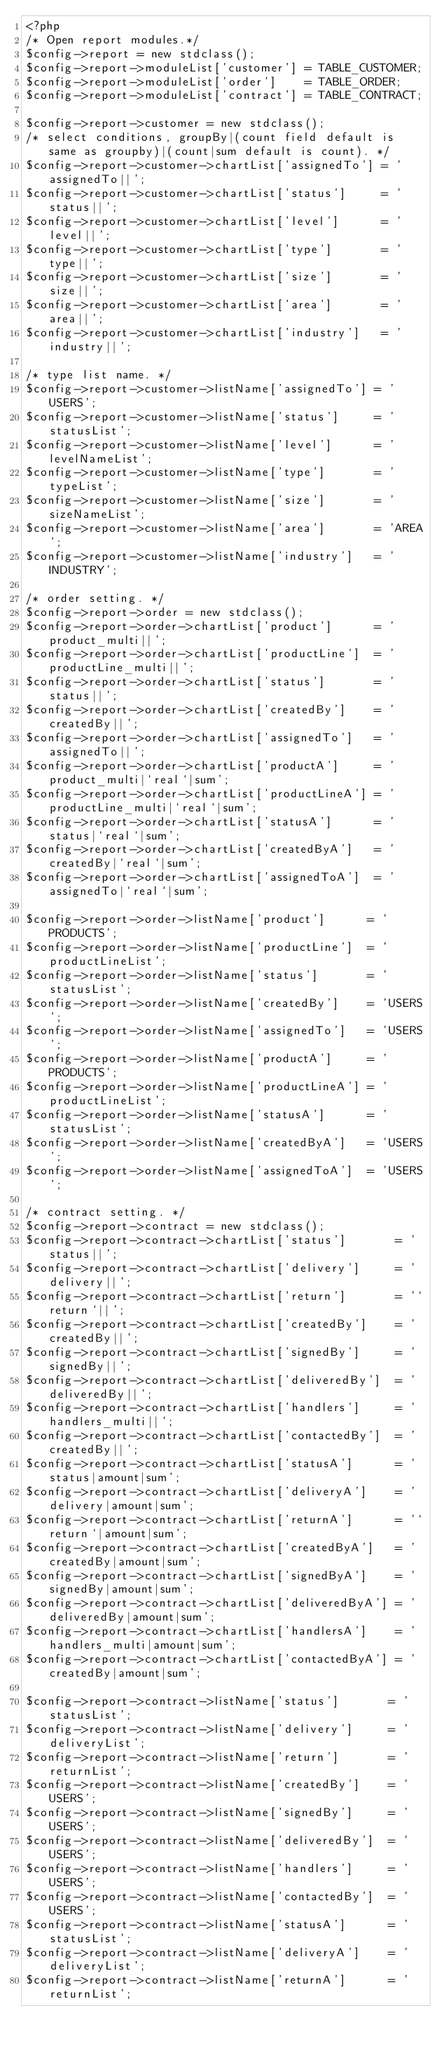Convert code to text. <code><loc_0><loc_0><loc_500><loc_500><_PHP_><?php
/* Open report modules.*/
$config->report = new stdclass();
$config->report->moduleList['customer'] = TABLE_CUSTOMER;
$config->report->moduleList['order']    = TABLE_ORDER;
$config->report->moduleList['contract'] = TABLE_CONTRACT;

$config->report->customer = new stdclass();
/* select conditions, groupBy|(count field default is same as groupby)|(count|sum default is count). */
$config->report->customer->chartList['assignedTo'] = 'assignedTo||';
$config->report->customer->chartList['status']     = 'status||';
$config->report->customer->chartList['level']      = 'level||';
$config->report->customer->chartList['type']       = 'type||';
$config->report->customer->chartList['size']       = 'size||';
$config->report->customer->chartList['area']       = 'area||';
$config->report->customer->chartList['industry']   = 'industry||';

/* type list name. */
$config->report->customer->listName['assignedTo'] = 'USERS';
$config->report->customer->listName['status']     = 'statusList';
$config->report->customer->listName['level']      = 'levelNameList';
$config->report->customer->listName['type']       = 'typeList';
$config->report->customer->listName['size']       = 'sizeNameList';
$config->report->customer->listName['area']       = 'AREA';
$config->report->customer->listName['industry']   = 'INDUSTRY';

/* order setting. */
$config->report->order = new stdclass();
$config->report->order->chartList['product']      = 'product_multi||';
$config->report->order->chartList['productLine']  = 'productLine_multi||';
$config->report->order->chartList['status']       = 'status||';
$config->report->order->chartList['createdBy']    = 'createdBy||';
$config->report->order->chartList['assignedTo']   = 'assignedTo||';
$config->report->order->chartList['productA']     = 'product_multi|`real`|sum';
$config->report->order->chartList['productLineA'] = 'productLine_multi|`real`|sum';
$config->report->order->chartList['statusA']      = 'status|`real`|sum';
$config->report->order->chartList['createdByA']   = 'createdBy|`real`|sum';
$config->report->order->chartList['assignedToA']  = 'assignedTo|`real`|sum';

$config->report->order->listName['product']      = 'PRODUCTS';
$config->report->order->listName['productLine']  = 'productLineList';
$config->report->order->listName['status']       = 'statusList';
$config->report->order->listName['createdBy']    = 'USERS';
$config->report->order->listName['assignedTo']   = 'USERS';
$config->report->order->listName['productA']     = 'PRODUCTS';
$config->report->order->listName['productLineA'] = 'productLineList';
$config->report->order->listName['statusA']      = 'statusList';
$config->report->order->listName['createdByA']   = 'USERS';
$config->report->order->listName['assignedToA']  = 'USERS';

/* contract setting. */
$config->report->contract = new stdclass();
$config->report->contract->chartList['status']       = 'status||';
$config->report->contract->chartList['delivery']     = 'delivery||';
$config->report->contract->chartList['return']       = '`return`||';
$config->report->contract->chartList['createdBy']    = 'createdBy||';
$config->report->contract->chartList['signedBy']     = 'signedBy||';
$config->report->contract->chartList['deliveredBy']  = 'deliveredBy||';
$config->report->contract->chartList['handlers']     = 'handlers_multi||';
$config->report->contract->chartList['contactedBy']  = 'createdBy||';
$config->report->contract->chartList['statusA']      = 'status|amount|sum';
$config->report->contract->chartList['deliveryA']    = 'delivery|amount|sum';
$config->report->contract->chartList['returnA']      = '`return`|amount|sum';
$config->report->contract->chartList['createdByA']   = 'createdBy|amount|sum';
$config->report->contract->chartList['signedByA']    = 'signedBy|amount|sum';
$config->report->contract->chartList['deliveredByA'] = 'deliveredBy|amount|sum';
$config->report->contract->chartList['handlersA']    = 'handlers_multi|amount|sum';
$config->report->contract->chartList['contactedByA'] = 'createdBy|amount|sum';

$config->report->contract->listName['status']       = 'statusList';
$config->report->contract->listName['delivery']     = 'deliveryList';
$config->report->contract->listName['return']       = 'returnList';
$config->report->contract->listName['createdBy']    = 'USERS';
$config->report->contract->listName['signedBy']     = 'USERS';
$config->report->contract->listName['deliveredBy']  = 'USERS';
$config->report->contract->listName['handlers']     = 'USERS';
$config->report->contract->listName['contactedBy']  = 'USERS';
$config->report->contract->listName['statusA']      = 'statusList';
$config->report->contract->listName['deliveryA']    = 'deliveryList';
$config->report->contract->listName['returnA']      = 'returnList';</code> 